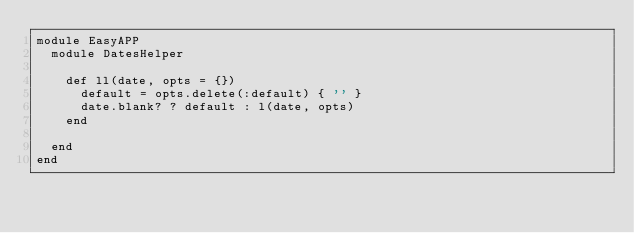<code> <loc_0><loc_0><loc_500><loc_500><_Ruby_>module EasyAPP
  module DatesHelper

    def ll(date, opts = {})
      default = opts.delete(:default) { '' }
      date.blank? ? default : l(date, opts)
    end

  end
end
</code> 